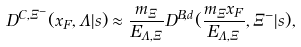Convert formula to latex. <formula><loc_0><loc_0><loc_500><loc_500>D ^ { C , \Xi ^ { - } } ( x _ { F } , \Lambda | s ) \approx \frac { m _ { \Xi } } { E _ { \Lambda , \Xi } } D ^ { B , d } ( \frac { m _ { \Xi } x _ { F } } { E _ { \Lambda , \Xi } } , \Xi ^ { - } | s ) ,</formula> 